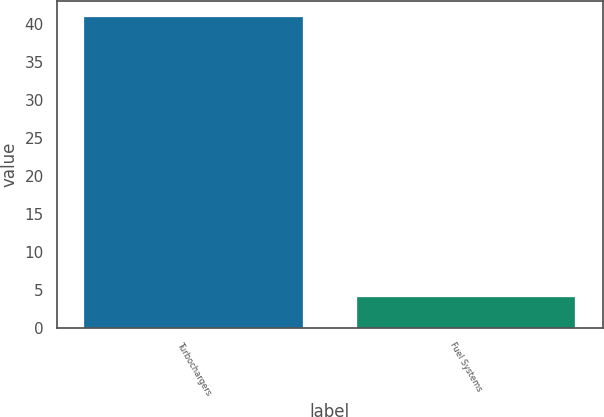<chart> <loc_0><loc_0><loc_500><loc_500><bar_chart><fcel>Turbochargers<fcel>Fuel Systems<nl><fcel>41<fcel>4<nl></chart> 